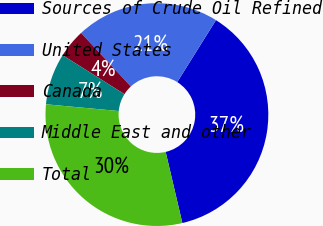Convert chart. <chart><loc_0><loc_0><loc_500><loc_500><pie_chart><fcel>Sources of Crude Oil Refined<fcel>United States<fcel>Canada<fcel>Middle East and other<fcel>Total<nl><fcel>37.43%<fcel>20.81%<fcel>4.14%<fcel>7.47%<fcel>30.14%<nl></chart> 